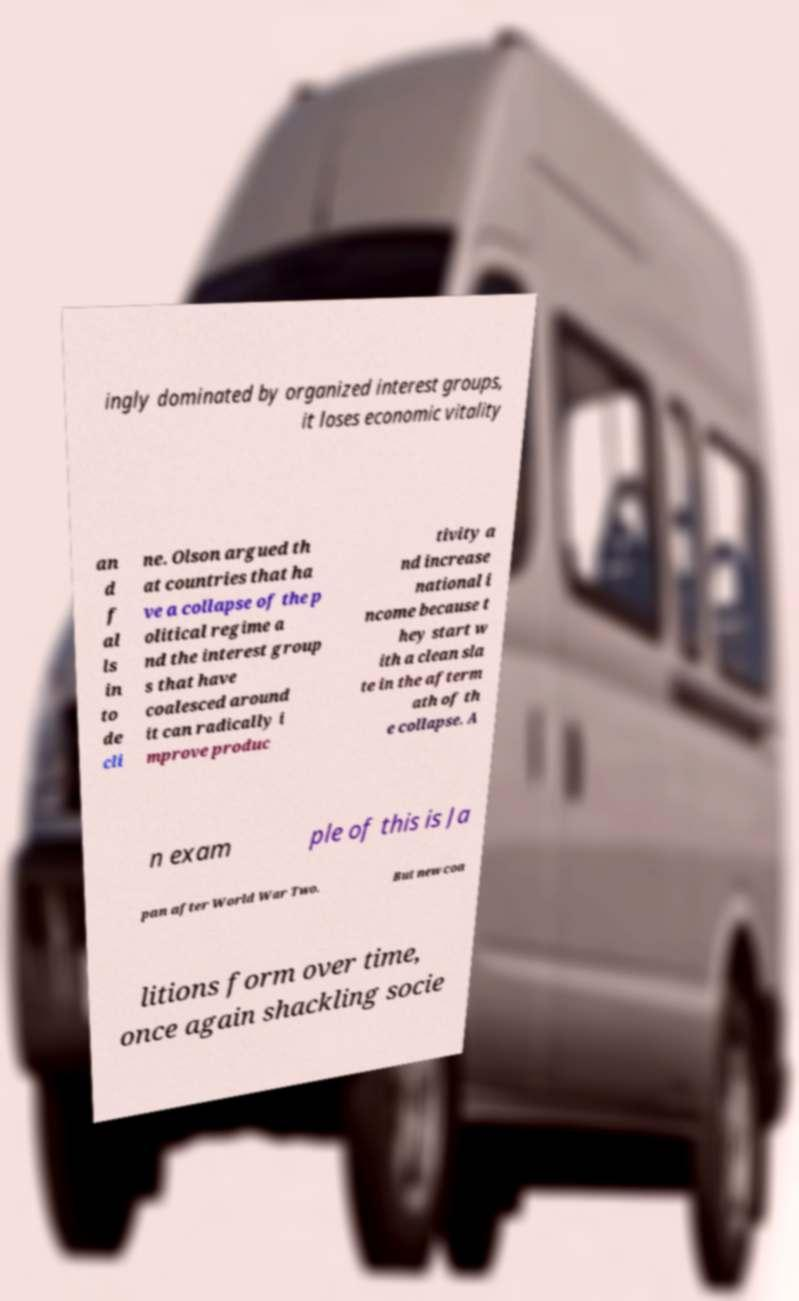Please identify and transcribe the text found in this image. ingly dominated by organized interest groups, it loses economic vitality an d f al ls in to de cli ne. Olson argued th at countries that ha ve a collapse of the p olitical regime a nd the interest group s that have coalesced around it can radically i mprove produc tivity a nd increase national i ncome because t hey start w ith a clean sla te in the afterm ath of th e collapse. A n exam ple of this is Ja pan after World War Two. But new coa litions form over time, once again shackling socie 